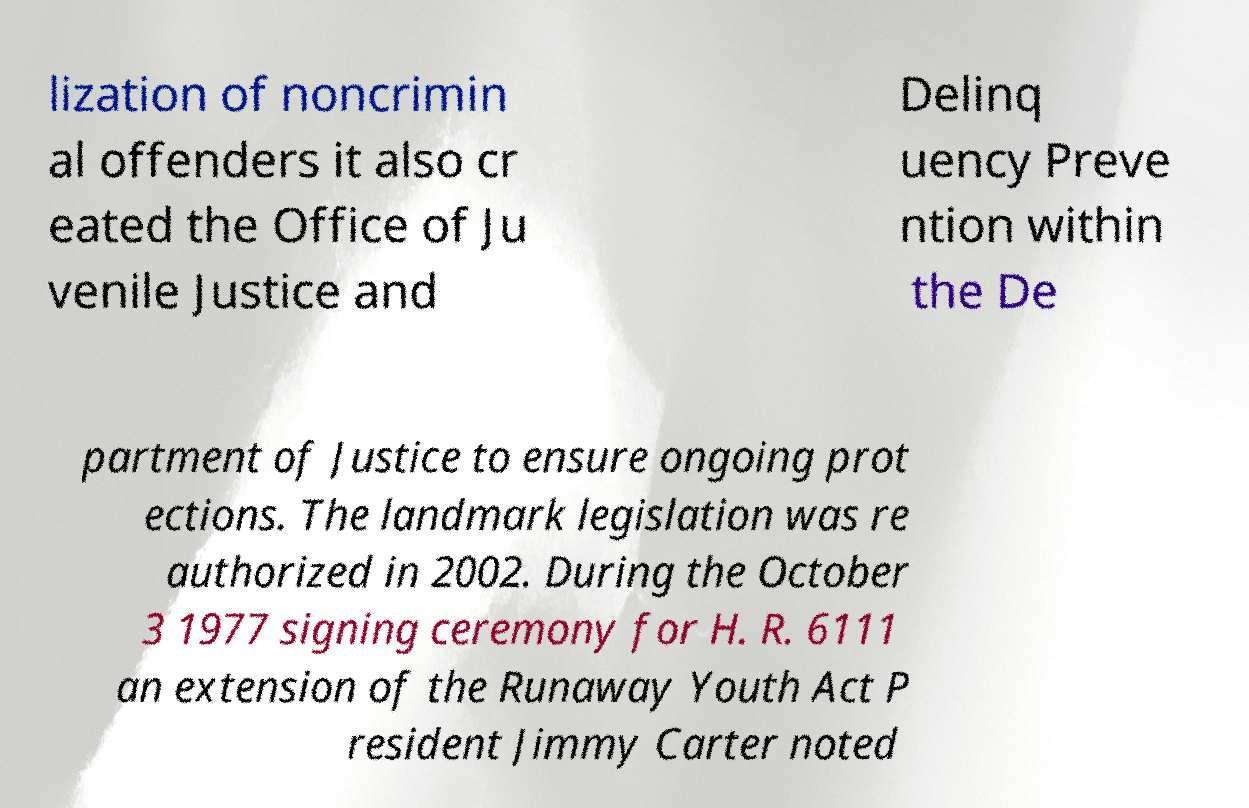There's text embedded in this image that I need extracted. Can you transcribe it verbatim? lization of noncrimin al offenders it also cr eated the Office of Ju venile Justice and Delinq uency Preve ntion within the De partment of Justice to ensure ongoing prot ections. The landmark legislation was re authorized in 2002. During the October 3 1977 signing ceremony for H. R. 6111 an extension of the Runaway Youth Act P resident Jimmy Carter noted 